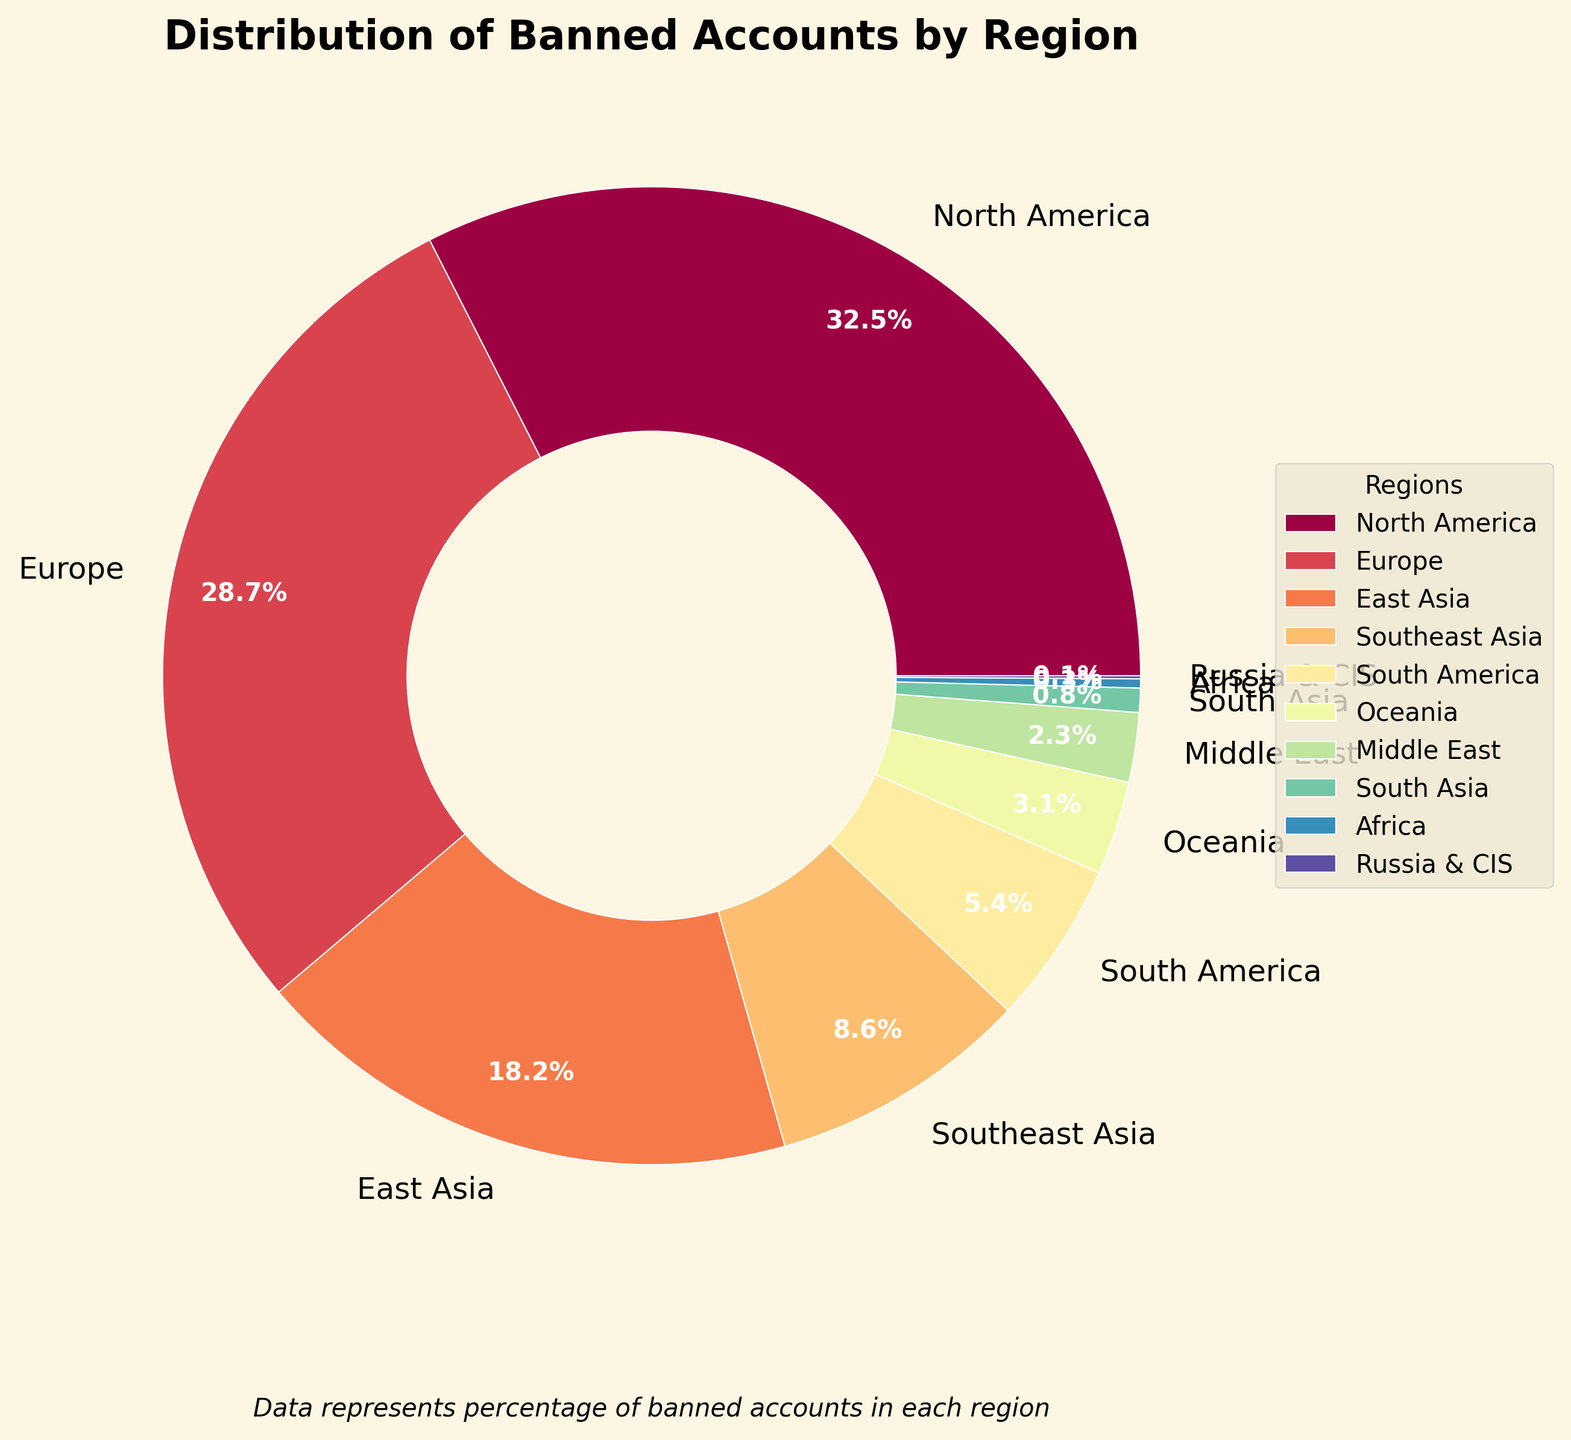What is the region with the highest percentage of banned accounts? The pie chart displays the percentage of banned accounts by region. North America, represented with the largest slice, has the highest percentage at 32.5%.
Answer: North America What is the combined percentage of banned accounts in East Asia and Southeast Asia? Sum the percentages for East Asia (18.2%) and Southeast Asia (8.6%). 18.2% + 8.6% = 26.8%.
Answer: 26.8% Which region has a lower percentage of banned accounts, Africa or Russia & CIS? The chart shows that Africa has 0.3% and Russia & CIS has 0.1%. Since 0.1% is lower than 0.3%, Russia & CIS has a lower percentage.
Answer: Russia & CIS How does the percentage of banned accounts in Europe compare to that in North America? Europe has 28.7% while North America has 32.5%. Since 32.5% is greater than 28.7%, North America has a higher percentage of banned accounts than Europe.
Answer: North America has a higher percentage than Europe What is the sum of the percentages of banned accounts for South America and Oceania? Sum the percentages of South America (5.4%) and Oceania (3.1%). 5.4% + 3.1% = 8.5%.
Answer: 8.5% Is the percentage of banned accounts in Middle East greater than that in South Asia? The pie chart shows Middle East with 2.3% and South Asia with 0.8%. Since 2.3% is greater than 0.8%, Middle East has a greater percentage of banned accounts.
Answer: Yes What is the approximate total percentage of banned accounts in regions with more than 20% share? Only North America (32.5%) and Europe (28.7%) have more than 20%. Sum these two percentages: 32.5% + 28.7% = 61.2%.
Answer: 61.2% How much more significant is the banned account percentage in East Asia compared to Oceania? Subtract the percentage of Oceania (3.1%) from East Asia (18.2%). 18.2% - 3.1% = 15.1%.
Answer: 15.1% What is the aggregate percentage of banned accounts in South Asia, Africa, and Russia & CIS? Sum the percentages: South Asia (0.8%) + Africa (0.3%) + Russia & CIS (0.1%). 0.8% + 0.3% + 0.1% = 1.2%.
Answer: 1.2% 